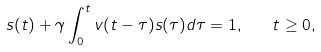<formula> <loc_0><loc_0><loc_500><loc_500>s ( t ) + \gamma \int _ { 0 } ^ { t } v ( t - \tau ) s ( \tau ) d \tau = 1 , \quad t \geq 0 ,</formula> 